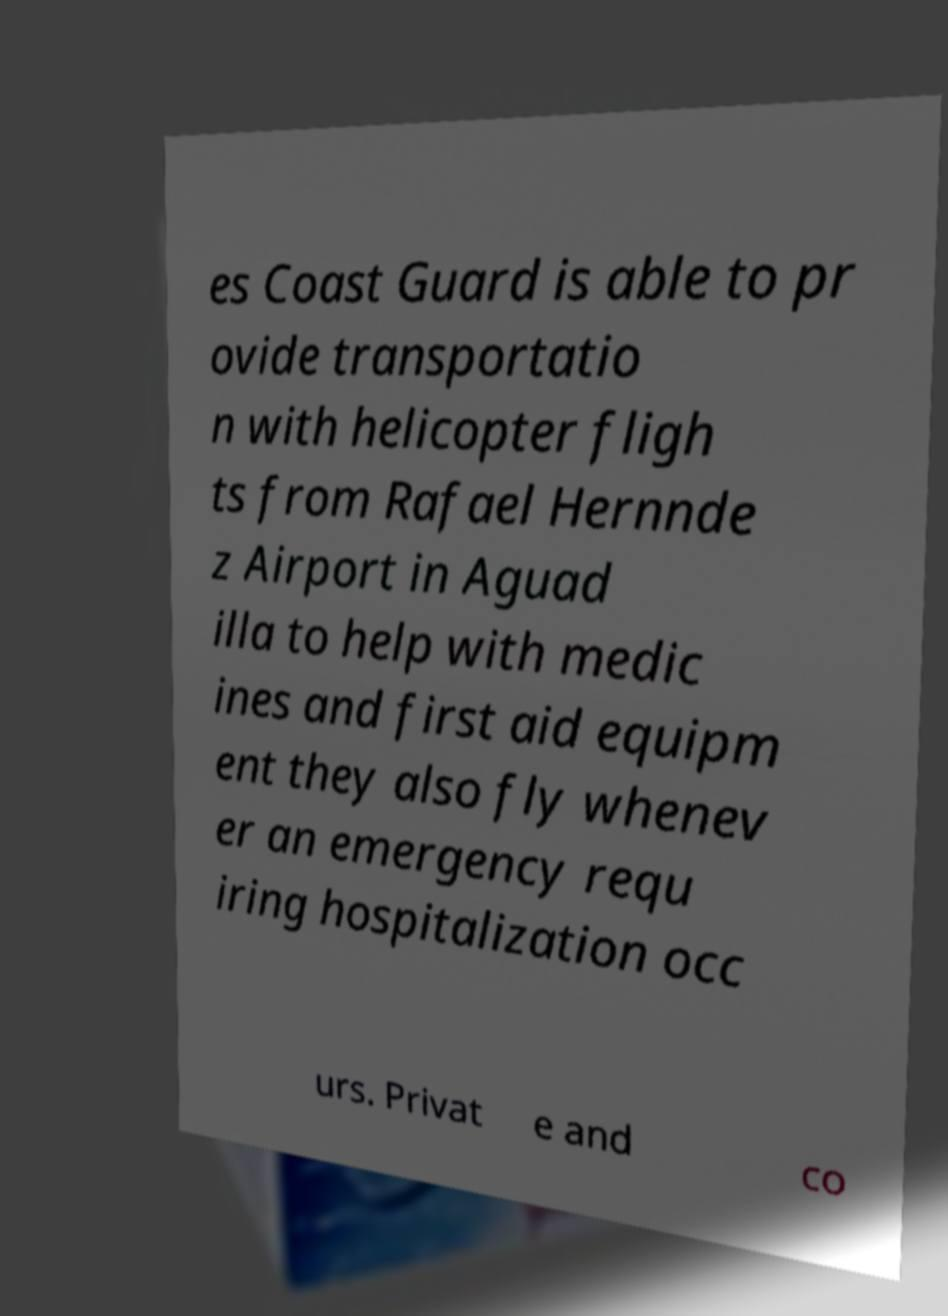There's text embedded in this image that I need extracted. Can you transcribe it verbatim? es Coast Guard is able to pr ovide transportatio n with helicopter fligh ts from Rafael Hernnde z Airport in Aguad illa to help with medic ines and first aid equipm ent they also fly whenev er an emergency requ iring hospitalization occ urs. Privat e and co 